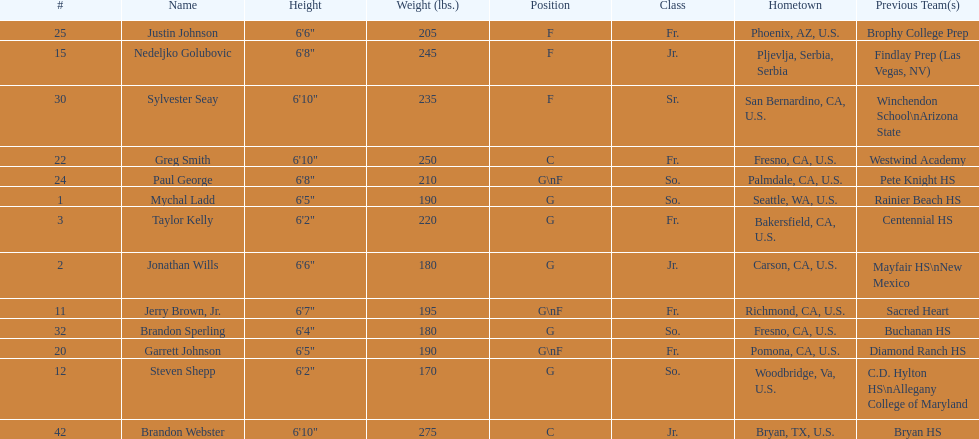Taylor kelly is shorter than 6' 3", which other player is also shorter than 6' 3"? Steven Shepp. 